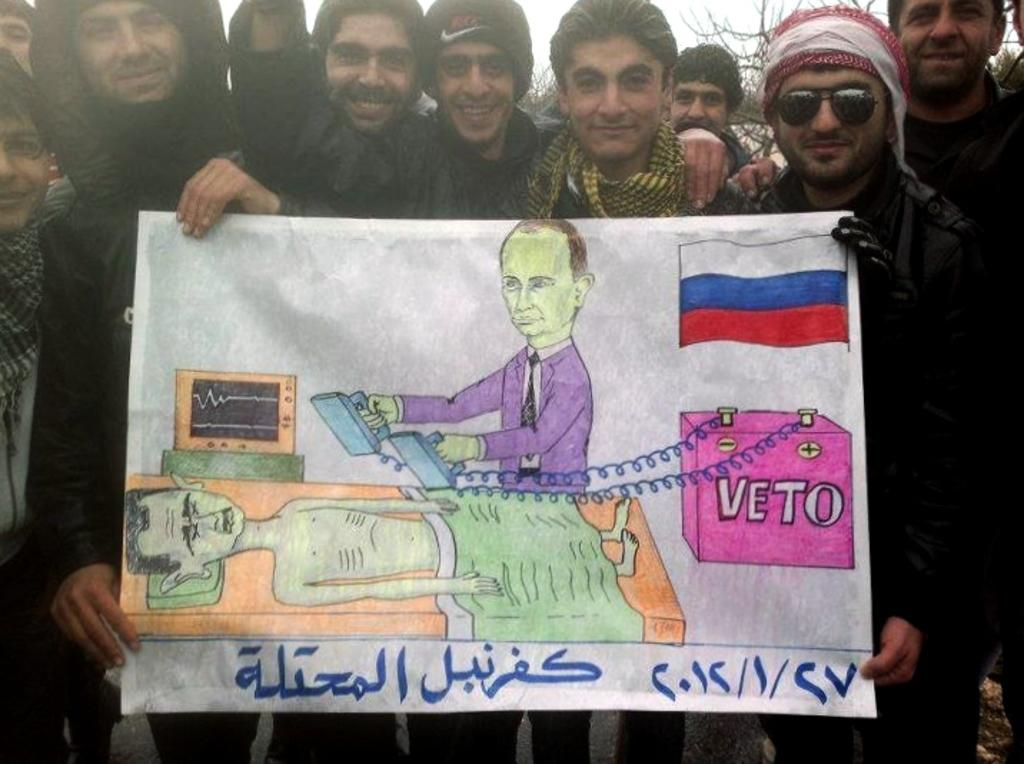What is happening with the group of people in the image? The people in the image are standing and smiling. What are the people holding in the image? The people are holding a paper. What can be seen in the background of the image? There are trees and the sky visible in the background of the image. What type of bird is flying in the image? There is no bird present in the image; it only features a group of people standing and smiling while holding a paper. 